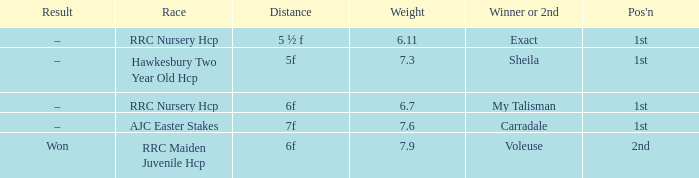What was the name of the champion or runner-up when the outcome was –, and weight was My Talisman. 